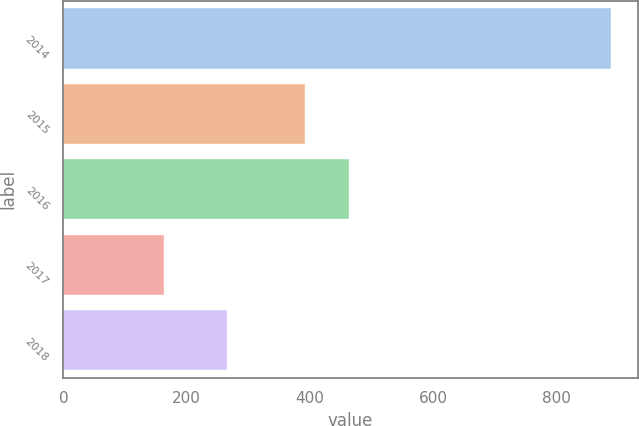<chart> <loc_0><loc_0><loc_500><loc_500><bar_chart><fcel>2014<fcel>2015<fcel>2016<fcel>2017<fcel>2018<nl><fcel>887<fcel>391<fcel>463.4<fcel>163<fcel>266<nl></chart> 